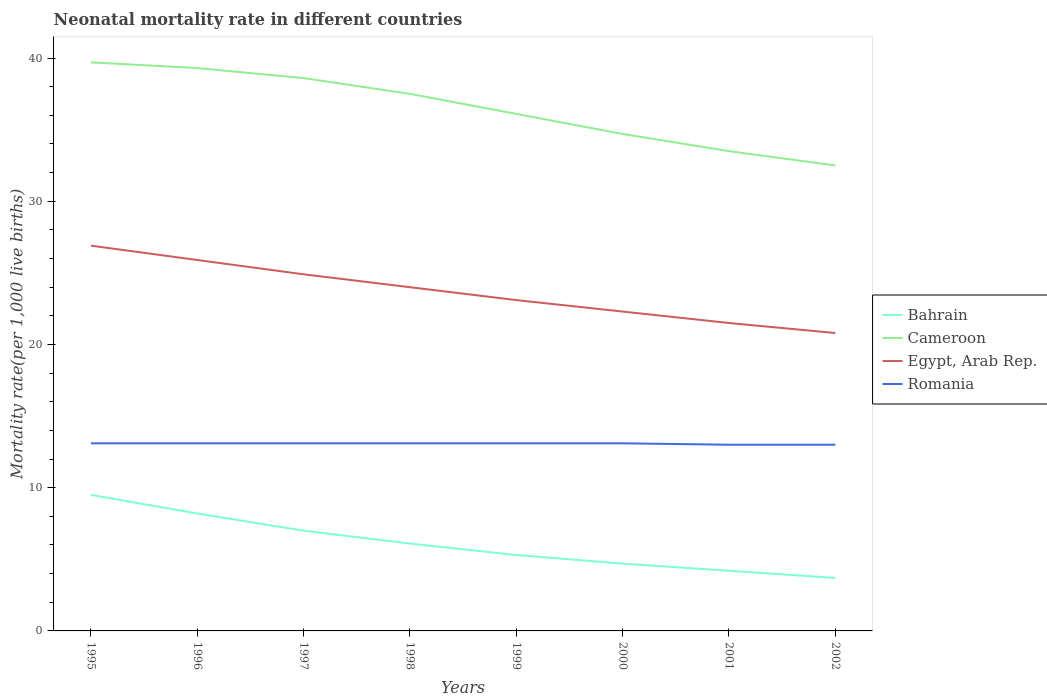How many different coloured lines are there?
Provide a short and direct response. 4. Does the line corresponding to Cameroon intersect with the line corresponding to Bahrain?
Offer a terse response. No. Is the number of lines equal to the number of legend labels?
Ensure brevity in your answer.  Yes. Across all years, what is the maximum neonatal mortality rate in Egypt, Arab Rep.?
Ensure brevity in your answer.  20.8. What is the difference between the highest and the lowest neonatal mortality rate in Cameroon?
Ensure brevity in your answer.  4. How many lines are there?
Provide a succinct answer. 4. Are the values on the major ticks of Y-axis written in scientific E-notation?
Your answer should be very brief. No. Where does the legend appear in the graph?
Your response must be concise. Center right. How many legend labels are there?
Your answer should be compact. 4. How are the legend labels stacked?
Ensure brevity in your answer.  Vertical. What is the title of the graph?
Ensure brevity in your answer.  Neonatal mortality rate in different countries. Does "Benin" appear as one of the legend labels in the graph?
Keep it short and to the point. No. What is the label or title of the X-axis?
Provide a short and direct response. Years. What is the label or title of the Y-axis?
Provide a succinct answer. Mortality rate(per 1,0 live births). What is the Mortality rate(per 1,000 live births) in Cameroon in 1995?
Give a very brief answer. 39.7. What is the Mortality rate(per 1,000 live births) in Egypt, Arab Rep. in 1995?
Your answer should be compact. 26.9. What is the Mortality rate(per 1,000 live births) in Romania in 1995?
Your answer should be very brief. 13.1. What is the Mortality rate(per 1,000 live births) of Cameroon in 1996?
Ensure brevity in your answer.  39.3. What is the Mortality rate(per 1,000 live births) in Egypt, Arab Rep. in 1996?
Your answer should be very brief. 25.9. What is the Mortality rate(per 1,000 live births) in Romania in 1996?
Offer a terse response. 13.1. What is the Mortality rate(per 1,000 live births) in Bahrain in 1997?
Give a very brief answer. 7. What is the Mortality rate(per 1,000 live births) of Cameroon in 1997?
Ensure brevity in your answer.  38.6. What is the Mortality rate(per 1,000 live births) of Egypt, Arab Rep. in 1997?
Offer a terse response. 24.9. What is the Mortality rate(per 1,000 live births) of Cameroon in 1998?
Offer a terse response. 37.5. What is the Mortality rate(per 1,000 live births) of Cameroon in 1999?
Your answer should be very brief. 36.1. What is the Mortality rate(per 1,000 live births) in Egypt, Arab Rep. in 1999?
Offer a terse response. 23.1. What is the Mortality rate(per 1,000 live births) in Romania in 1999?
Your answer should be very brief. 13.1. What is the Mortality rate(per 1,000 live births) in Bahrain in 2000?
Ensure brevity in your answer.  4.7. What is the Mortality rate(per 1,000 live births) in Cameroon in 2000?
Make the answer very short. 34.7. What is the Mortality rate(per 1,000 live births) in Egypt, Arab Rep. in 2000?
Your answer should be compact. 22.3. What is the Mortality rate(per 1,000 live births) in Romania in 2000?
Ensure brevity in your answer.  13.1. What is the Mortality rate(per 1,000 live births) of Bahrain in 2001?
Give a very brief answer. 4.2. What is the Mortality rate(per 1,000 live births) in Cameroon in 2001?
Offer a very short reply. 33.5. What is the Mortality rate(per 1,000 live births) in Romania in 2001?
Your response must be concise. 13. What is the Mortality rate(per 1,000 live births) in Cameroon in 2002?
Make the answer very short. 32.5. What is the Mortality rate(per 1,000 live births) in Egypt, Arab Rep. in 2002?
Provide a short and direct response. 20.8. Across all years, what is the maximum Mortality rate(per 1,000 live births) in Cameroon?
Provide a short and direct response. 39.7. Across all years, what is the maximum Mortality rate(per 1,000 live births) in Egypt, Arab Rep.?
Offer a terse response. 26.9. Across all years, what is the minimum Mortality rate(per 1,000 live births) in Cameroon?
Ensure brevity in your answer.  32.5. Across all years, what is the minimum Mortality rate(per 1,000 live births) in Egypt, Arab Rep.?
Give a very brief answer. 20.8. What is the total Mortality rate(per 1,000 live births) of Bahrain in the graph?
Offer a terse response. 48.7. What is the total Mortality rate(per 1,000 live births) of Cameroon in the graph?
Your answer should be compact. 291.9. What is the total Mortality rate(per 1,000 live births) of Egypt, Arab Rep. in the graph?
Keep it short and to the point. 189.4. What is the total Mortality rate(per 1,000 live births) in Romania in the graph?
Your answer should be compact. 104.6. What is the difference between the Mortality rate(per 1,000 live births) in Cameroon in 1995 and that in 1996?
Ensure brevity in your answer.  0.4. What is the difference between the Mortality rate(per 1,000 live births) in Egypt, Arab Rep. in 1995 and that in 1996?
Ensure brevity in your answer.  1. What is the difference between the Mortality rate(per 1,000 live births) of Romania in 1995 and that in 1996?
Your answer should be very brief. 0. What is the difference between the Mortality rate(per 1,000 live births) in Bahrain in 1995 and that in 1997?
Offer a very short reply. 2.5. What is the difference between the Mortality rate(per 1,000 live births) in Bahrain in 1995 and that in 1998?
Ensure brevity in your answer.  3.4. What is the difference between the Mortality rate(per 1,000 live births) in Cameroon in 1995 and that in 1998?
Offer a terse response. 2.2. What is the difference between the Mortality rate(per 1,000 live births) of Egypt, Arab Rep. in 1995 and that in 1998?
Ensure brevity in your answer.  2.9. What is the difference between the Mortality rate(per 1,000 live births) of Romania in 1995 and that in 1998?
Your answer should be compact. 0. What is the difference between the Mortality rate(per 1,000 live births) of Bahrain in 1995 and that in 1999?
Make the answer very short. 4.2. What is the difference between the Mortality rate(per 1,000 live births) of Cameroon in 1995 and that in 1999?
Your answer should be very brief. 3.6. What is the difference between the Mortality rate(per 1,000 live births) of Egypt, Arab Rep. in 1995 and that in 1999?
Keep it short and to the point. 3.8. What is the difference between the Mortality rate(per 1,000 live births) of Egypt, Arab Rep. in 1995 and that in 2000?
Keep it short and to the point. 4.6. What is the difference between the Mortality rate(per 1,000 live births) of Bahrain in 1995 and that in 2001?
Offer a terse response. 5.3. What is the difference between the Mortality rate(per 1,000 live births) of Romania in 1995 and that in 2001?
Keep it short and to the point. 0.1. What is the difference between the Mortality rate(per 1,000 live births) of Cameroon in 1995 and that in 2002?
Give a very brief answer. 7.2. What is the difference between the Mortality rate(per 1,000 live births) of Romania in 1995 and that in 2002?
Provide a short and direct response. 0.1. What is the difference between the Mortality rate(per 1,000 live births) in Bahrain in 1996 and that in 1997?
Provide a succinct answer. 1.2. What is the difference between the Mortality rate(per 1,000 live births) of Egypt, Arab Rep. in 1996 and that in 1997?
Offer a terse response. 1. What is the difference between the Mortality rate(per 1,000 live births) of Romania in 1996 and that in 1997?
Your answer should be very brief. 0. What is the difference between the Mortality rate(per 1,000 live births) in Egypt, Arab Rep. in 1996 and that in 1998?
Your answer should be compact. 1.9. What is the difference between the Mortality rate(per 1,000 live births) of Romania in 1996 and that in 1998?
Keep it short and to the point. 0. What is the difference between the Mortality rate(per 1,000 live births) of Bahrain in 1996 and that in 1999?
Provide a succinct answer. 2.9. What is the difference between the Mortality rate(per 1,000 live births) in Cameroon in 1996 and that in 1999?
Provide a short and direct response. 3.2. What is the difference between the Mortality rate(per 1,000 live births) of Romania in 1996 and that in 1999?
Offer a very short reply. 0. What is the difference between the Mortality rate(per 1,000 live births) in Bahrain in 1996 and that in 2000?
Ensure brevity in your answer.  3.5. What is the difference between the Mortality rate(per 1,000 live births) of Egypt, Arab Rep. in 1996 and that in 2000?
Offer a terse response. 3.6. What is the difference between the Mortality rate(per 1,000 live births) in Bahrain in 1996 and that in 2001?
Keep it short and to the point. 4. What is the difference between the Mortality rate(per 1,000 live births) of Cameroon in 1996 and that in 2001?
Offer a very short reply. 5.8. What is the difference between the Mortality rate(per 1,000 live births) in Egypt, Arab Rep. in 1996 and that in 2001?
Provide a short and direct response. 4.4. What is the difference between the Mortality rate(per 1,000 live births) of Egypt, Arab Rep. in 1996 and that in 2002?
Your answer should be compact. 5.1. What is the difference between the Mortality rate(per 1,000 live births) in Bahrain in 1997 and that in 1998?
Your answer should be compact. 0.9. What is the difference between the Mortality rate(per 1,000 live births) in Cameroon in 1997 and that in 1998?
Make the answer very short. 1.1. What is the difference between the Mortality rate(per 1,000 live births) in Egypt, Arab Rep. in 1997 and that in 1999?
Keep it short and to the point. 1.8. What is the difference between the Mortality rate(per 1,000 live births) of Romania in 1997 and that in 1999?
Provide a succinct answer. 0. What is the difference between the Mortality rate(per 1,000 live births) of Bahrain in 1997 and that in 2000?
Make the answer very short. 2.3. What is the difference between the Mortality rate(per 1,000 live births) of Cameroon in 1997 and that in 2000?
Provide a succinct answer. 3.9. What is the difference between the Mortality rate(per 1,000 live births) in Cameroon in 1997 and that in 2001?
Your answer should be compact. 5.1. What is the difference between the Mortality rate(per 1,000 live births) of Egypt, Arab Rep. in 1997 and that in 2001?
Give a very brief answer. 3.4. What is the difference between the Mortality rate(per 1,000 live births) of Bahrain in 1997 and that in 2002?
Make the answer very short. 3.3. What is the difference between the Mortality rate(per 1,000 live births) in Cameroon in 1997 and that in 2002?
Your response must be concise. 6.1. What is the difference between the Mortality rate(per 1,000 live births) of Egypt, Arab Rep. in 1997 and that in 2002?
Provide a short and direct response. 4.1. What is the difference between the Mortality rate(per 1,000 live births) of Bahrain in 1998 and that in 1999?
Provide a short and direct response. 0.8. What is the difference between the Mortality rate(per 1,000 live births) in Cameroon in 1998 and that in 1999?
Your answer should be compact. 1.4. What is the difference between the Mortality rate(per 1,000 live births) in Egypt, Arab Rep. in 1998 and that in 1999?
Your response must be concise. 0.9. What is the difference between the Mortality rate(per 1,000 live births) of Bahrain in 1998 and that in 2000?
Give a very brief answer. 1.4. What is the difference between the Mortality rate(per 1,000 live births) of Egypt, Arab Rep. in 1998 and that in 2000?
Provide a short and direct response. 1.7. What is the difference between the Mortality rate(per 1,000 live births) of Romania in 1998 and that in 2000?
Offer a very short reply. 0. What is the difference between the Mortality rate(per 1,000 live births) in Bahrain in 1998 and that in 2001?
Provide a short and direct response. 1.9. What is the difference between the Mortality rate(per 1,000 live births) in Bahrain in 1998 and that in 2002?
Your answer should be compact. 2.4. What is the difference between the Mortality rate(per 1,000 live births) of Egypt, Arab Rep. in 1998 and that in 2002?
Keep it short and to the point. 3.2. What is the difference between the Mortality rate(per 1,000 live births) of Cameroon in 1999 and that in 2000?
Your answer should be very brief. 1.4. What is the difference between the Mortality rate(per 1,000 live births) in Bahrain in 1999 and that in 2001?
Ensure brevity in your answer.  1.1. What is the difference between the Mortality rate(per 1,000 live births) of Romania in 1999 and that in 2001?
Your answer should be very brief. 0.1. What is the difference between the Mortality rate(per 1,000 live births) of Cameroon in 1999 and that in 2002?
Your response must be concise. 3.6. What is the difference between the Mortality rate(per 1,000 live births) in Cameroon in 2000 and that in 2001?
Provide a succinct answer. 1.2. What is the difference between the Mortality rate(per 1,000 live births) of Egypt, Arab Rep. in 2000 and that in 2001?
Your response must be concise. 0.8. What is the difference between the Mortality rate(per 1,000 live births) of Bahrain in 2000 and that in 2002?
Your response must be concise. 1. What is the difference between the Mortality rate(per 1,000 live births) in Egypt, Arab Rep. in 2000 and that in 2002?
Ensure brevity in your answer.  1.5. What is the difference between the Mortality rate(per 1,000 live births) in Bahrain in 1995 and the Mortality rate(per 1,000 live births) in Cameroon in 1996?
Provide a short and direct response. -29.8. What is the difference between the Mortality rate(per 1,000 live births) in Bahrain in 1995 and the Mortality rate(per 1,000 live births) in Egypt, Arab Rep. in 1996?
Give a very brief answer. -16.4. What is the difference between the Mortality rate(per 1,000 live births) of Cameroon in 1995 and the Mortality rate(per 1,000 live births) of Romania in 1996?
Ensure brevity in your answer.  26.6. What is the difference between the Mortality rate(per 1,000 live births) in Bahrain in 1995 and the Mortality rate(per 1,000 live births) in Cameroon in 1997?
Ensure brevity in your answer.  -29.1. What is the difference between the Mortality rate(per 1,000 live births) of Bahrain in 1995 and the Mortality rate(per 1,000 live births) of Egypt, Arab Rep. in 1997?
Provide a short and direct response. -15.4. What is the difference between the Mortality rate(per 1,000 live births) in Cameroon in 1995 and the Mortality rate(per 1,000 live births) in Egypt, Arab Rep. in 1997?
Give a very brief answer. 14.8. What is the difference between the Mortality rate(per 1,000 live births) of Cameroon in 1995 and the Mortality rate(per 1,000 live births) of Romania in 1997?
Offer a very short reply. 26.6. What is the difference between the Mortality rate(per 1,000 live births) in Bahrain in 1995 and the Mortality rate(per 1,000 live births) in Cameroon in 1998?
Make the answer very short. -28. What is the difference between the Mortality rate(per 1,000 live births) in Cameroon in 1995 and the Mortality rate(per 1,000 live births) in Romania in 1998?
Make the answer very short. 26.6. What is the difference between the Mortality rate(per 1,000 live births) in Bahrain in 1995 and the Mortality rate(per 1,000 live births) in Cameroon in 1999?
Provide a succinct answer. -26.6. What is the difference between the Mortality rate(per 1,000 live births) in Bahrain in 1995 and the Mortality rate(per 1,000 live births) in Romania in 1999?
Your answer should be very brief. -3.6. What is the difference between the Mortality rate(per 1,000 live births) in Cameroon in 1995 and the Mortality rate(per 1,000 live births) in Egypt, Arab Rep. in 1999?
Give a very brief answer. 16.6. What is the difference between the Mortality rate(per 1,000 live births) in Cameroon in 1995 and the Mortality rate(per 1,000 live births) in Romania in 1999?
Your response must be concise. 26.6. What is the difference between the Mortality rate(per 1,000 live births) in Egypt, Arab Rep. in 1995 and the Mortality rate(per 1,000 live births) in Romania in 1999?
Ensure brevity in your answer.  13.8. What is the difference between the Mortality rate(per 1,000 live births) in Bahrain in 1995 and the Mortality rate(per 1,000 live births) in Cameroon in 2000?
Keep it short and to the point. -25.2. What is the difference between the Mortality rate(per 1,000 live births) of Cameroon in 1995 and the Mortality rate(per 1,000 live births) of Egypt, Arab Rep. in 2000?
Give a very brief answer. 17.4. What is the difference between the Mortality rate(per 1,000 live births) of Cameroon in 1995 and the Mortality rate(per 1,000 live births) of Romania in 2000?
Your response must be concise. 26.6. What is the difference between the Mortality rate(per 1,000 live births) of Bahrain in 1995 and the Mortality rate(per 1,000 live births) of Cameroon in 2001?
Make the answer very short. -24. What is the difference between the Mortality rate(per 1,000 live births) in Bahrain in 1995 and the Mortality rate(per 1,000 live births) in Egypt, Arab Rep. in 2001?
Your answer should be very brief. -12. What is the difference between the Mortality rate(per 1,000 live births) of Bahrain in 1995 and the Mortality rate(per 1,000 live births) of Romania in 2001?
Your answer should be very brief. -3.5. What is the difference between the Mortality rate(per 1,000 live births) in Cameroon in 1995 and the Mortality rate(per 1,000 live births) in Romania in 2001?
Provide a short and direct response. 26.7. What is the difference between the Mortality rate(per 1,000 live births) in Bahrain in 1995 and the Mortality rate(per 1,000 live births) in Egypt, Arab Rep. in 2002?
Offer a very short reply. -11.3. What is the difference between the Mortality rate(per 1,000 live births) of Bahrain in 1995 and the Mortality rate(per 1,000 live births) of Romania in 2002?
Your response must be concise. -3.5. What is the difference between the Mortality rate(per 1,000 live births) of Cameroon in 1995 and the Mortality rate(per 1,000 live births) of Romania in 2002?
Give a very brief answer. 26.7. What is the difference between the Mortality rate(per 1,000 live births) of Egypt, Arab Rep. in 1995 and the Mortality rate(per 1,000 live births) of Romania in 2002?
Your answer should be compact. 13.9. What is the difference between the Mortality rate(per 1,000 live births) of Bahrain in 1996 and the Mortality rate(per 1,000 live births) of Cameroon in 1997?
Give a very brief answer. -30.4. What is the difference between the Mortality rate(per 1,000 live births) of Bahrain in 1996 and the Mortality rate(per 1,000 live births) of Egypt, Arab Rep. in 1997?
Offer a very short reply. -16.7. What is the difference between the Mortality rate(per 1,000 live births) of Cameroon in 1996 and the Mortality rate(per 1,000 live births) of Egypt, Arab Rep. in 1997?
Keep it short and to the point. 14.4. What is the difference between the Mortality rate(per 1,000 live births) of Cameroon in 1996 and the Mortality rate(per 1,000 live births) of Romania in 1997?
Offer a very short reply. 26.2. What is the difference between the Mortality rate(per 1,000 live births) of Bahrain in 1996 and the Mortality rate(per 1,000 live births) of Cameroon in 1998?
Provide a short and direct response. -29.3. What is the difference between the Mortality rate(per 1,000 live births) of Bahrain in 1996 and the Mortality rate(per 1,000 live births) of Egypt, Arab Rep. in 1998?
Your response must be concise. -15.8. What is the difference between the Mortality rate(per 1,000 live births) of Bahrain in 1996 and the Mortality rate(per 1,000 live births) of Romania in 1998?
Your response must be concise. -4.9. What is the difference between the Mortality rate(per 1,000 live births) of Cameroon in 1996 and the Mortality rate(per 1,000 live births) of Egypt, Arab Rep. in 1998?
Your answer should be very brief. 15.3. What is the difference between the Mortality rate(per 1,000 live births) of Cameroon in 1996 and the Mortality rate(per 1,000 live births) of Romania in 1998?
Provide a succinct answer. 26.2. What is the difference between the Mortality rate(per 1,000 live births) in Egypt, Arab Rep. in 1996 and the Mortality rate(per 1,000 live births) in Romania in 1998?
Make the answer very short. 12.8. What is the difference between the Mortality rate(per 1,000 live births) in Bahrain in 1996 and the Mortality rate(per 1,000 live births) in Cameroon in 1999?
Your answer should be compact. -27.9. What is the difference between the Mortality rate(per 1,000 live births) in Bahrain in 1996 and the Mortality rate(per 1,000 live births) in Egypt, Arab Rep. in 1999?
Give a very brief answer. -14.9. What is the difference between the Mortality rate(per 1,000 live births) of Cameroon in 1996 and the Mortality rate(per 1,000 live births) of Egypt, Arab Rep. in 1999?
Your response must be concise. 16.2. What is the difference between the Mortality rate(per 1,000 live births) of Cameroon in 1996 and the Mortality rate(per 1,000 live births) of Romania in 1999?
Offer a terse response. 26.2. What is the difference between the Mortality rate(per 1,000 live births) of Bahrain in 1996 and the Mortality rate(per 1,000 live births) of Cameroon in 2000?
Make the answer very short. -26.5. What is the difference between the Mortality rate(per 1,000 live births) in Bahrain in 1996 and the Mortality rate(per 1,000 live births) in Egypt, Arab Rep. in 2000?
Make the answer very short. -14.1. What is the difference between the Mortality rate(per 1,000 live births) in Cameroon in 1996 and the Mortality rate(per 1,000 live births) in Romania in 2000?
Keep it short and to the point. 26.2. What is the difference between the Mortality rate(per 1,000 live births) in Bahrain in 1996 and the Mortality rate(per 1,000 live births) in Cameroon in 2001?
Your answer should be very brief. -25.3. What is the difference between the Mortality rate(per 1,000 live births) in Bahrain in 1996 and the Mortality rate(per 1,000 live births) in Romania in 2001?
Provide a succinct answer. -4.8. What is the difference between the Mortality rate(per 1,000 live births) in Cameroon in 1996 and the Mortality rate(per 1,000 live births) in Egypt, Arab Rep. in 2001?
Ensure brevity in your answer.  17.8. What is the difference between the Mortality rate(per 1,000 live births) of Cameroon in 1996 and the Mortality rate(per 1,000 live births) of Romania in 2001?
Your answer should be very brief. 26.3. What is the difference between the Mortality rate(per 1,000 live births) in Bahrain in 1996 and the Mortality rate(per 1,000 live births) in Cameroon in 2002?
Make the answer very short. -24.3. What is the difference between the Mortality rate(per 1,000 live births) of Cameroon in 1996 and the Mortality rate(per 1,000 live births) of Romania in 2002?
Offer a terse response. 26.3. What is the difference between the Mortality rate(per 1,000 live births) in Bahrain in 1997 and the Mortality rate(per 1,000 live births) in Cameroon in 1998?
Give a very brief answer. -30.5. What is the difference between the Mortality rate(per 1,000 live births) in Bahrain in 1997 and the Mortality rate(per 1,000 live births) in Egypt, Arab Rep. in 1998?
Give a very brief answer. -17. What is the difference between the Mortality rate(per 1,000 live births) of Bahrain in 1997 and the Mortality rate(per 1,000 live births) of Romania in 1998?
Provide a succinct answer. -6.1. What is the difference between the Mortality rate(per 1,000 live births) of Cameroon in 1997 and the Mortality rate(per 1,000 live births) of Romania in 1998?
Ensure brevity in your answer.  25.5. What is the difference between the Mortality rate(per 1,000 live births) of Egypt, Arab Rep. in 1997 and the Mortality rate(per 1,000 live births) of Romania in 1998?
Your answer should be very brief. 11.8. What is the difference between the Mortality rate(per 1,000 live births) in Bahrain in 1997 and the Mortality rate(per 1,000 live births) in Cameroon in 1999?
Provide a succinct answer. -29.1. What is the difference between the Mortality rate(per 1,000 live births) of Bahrain in 1997 and the Mortality rate(per 1,000 live births) of Egypt, Arab Rep. in 1999?
Your answer should be very brief. -16.1. What is the difference between the Mortality rate(per 1,000 live births) in Cameroon in 1997 and the Mortality rate(per 1,000 live births) in Egypt, Arab Rep. in 1999?
Make the answer very short. 15.5. What is the difference between the Mortality rate(per 1,000 live births) in Egypt, Arab Rep. in 1997 and the Mortality rate(per 1,000 live births) in Romania in 1999?
Your answer should be very brief. 11.8. What is the difference between the Mortality rate(per 1,000 live births) in Bahrain in 1997 and the Mortality rate(per 1,000 live births) in Cameroon in 2000?
Your answer should be compact. -27.7. What is the difference between the Mortality rate(per 1,000 live births) in Bahrain in 1997 and the Mortality rate(per 1,000 live births) in Egypt, Arab Rep. in 2000?
Provide a short and direct response. -15.3. What is the difference between the Mortality rate(per 1,000 live births) in Cameroon in 1997 and the Mortality rate(per 1,000 live births) in Egypt, Arab Rep. in 2000?
Give a very brief answer. 16.3. What is the difference between the Mortality rate(per 1,000 live births) of Bahrain in 1997 and the Mortality rate(per 1,000 live births) of Cameroon in 2001?
Your answer should be compact. -26.5. What is the difference between the Mortality rate(per 1,000 live births) of Bahrain in 1997 and the Mortality rate(per 1,000 live births) of Romania in 2001?
Ensure brevity in your answer.  -6. What is the difference between the Mortality rate(per 1,000 live births) in Cameroon in 1997 and the Mortality rate(per 1,000 live births) in Egypt, Arab Rep. in 2001?
Ensure brevity in your answer.  17.1. What is the difference between the Mortality rate(per 1,000 live births) of Cameroon in 1997 and the Mortality rate(per 1,000 live births) of Romania in 2001?
Keep it short and to the point. 25.6. What is the difference between the Mortality rate(per 1,000 live births) in Egypt, Arab Rep. in 1997 and the Mortality rate(per 1,000 live births) in Romania in 2001?
Give a very brief answer. 11.9. What is the difference between the Mortality rate(per 1,000 live births) of Bahrain in 1997 and the Mortality rate(per 1,000 live births) of Cameroon in 2002?
Give a very brief answer. -25.5. What is the difference between the Mortality rate(per 1,000 live births) of Bahrain in 1997 and the Mortality rate(per 1,000 live births) of Egypt, Arab Rep. in 2002?
Offer a very short reply. -13.8. What is the difference between the Mortality rate(per 1,000 live births) of Bahrain in 1997 and the Mortality rate(per 1,000 live births) of Romania in 2002?
Keep it short and to the point. -6. What is the difference between the Mortality rate(per 1,000 live births) of Cameroon in 1997 and the Mortality rate(per 1,000 live births) of Romania in 2002?
Offer a very short reply. 25.6. What is the difference between the Mortality rate(per 1,000 live births) in Egypt, Arab Rep. in 1997 and the Mortality rate(per 1,000 live births) in Romania in 2002?
Keep it short and to the point. 11.9. What is the difference between the Mortality rate(per 1,000 live births) in Bahrain in 1998 and the Mortality rate(per 1,000 live births) in Egypt, Arab Rep. in 1999?
Your response must be concise. -17. What is the difference between the Mortality rate(per 1,000 live births) of Bahrain in 1998 and the Mortality rate(per 1,000 live births) of Romania in 1999?
Ensure brevity in your answer.  -7. What is the difference between the Mortality rate(per 1,000 live births) in Cameroon in 1998 and the Mortality rate(per 1,000 live births) in Romania in 1999?
Provide a succinct answer. 24.4. What is the difference between the Mortality rate(per 1,000 live births) in Bahrain in 1998 and the Mortality rate(per 1,000 live births) in Cameroon in 2000?
Make the answer very short. -28.6. What is the difference between the Mortality rate(per 1,000 live births) of Bahrain in 1998 and the Mortality rate(per 1,000 live births) of Egypt, Arab Rep. in 2000?
Keep it short and to the point. -16.2. What is the difference between the Mortality rate(per 1,000 live births) of Bahrain in 1998 and the Mortality rate(per 1,000 live births) of Romania in 2000?
Give a very brief answer. -7. What is the difference between the Mortality rate(per 1,000 live births) of Cameroon in 1998 and the Mortality rate(per 1,000 live births) of Egypt, Arab Rep. in 2000?
Ensure brevity in your answer.  15.2. What is the difference between the Mortality rate(per 1,000 live births) of Cameroon in 1998 and the Mortality rate(per 1,000 live births) of Romania in 2000?
Make the answer very short. 24.4. What is the difference between the Mortality rate(per 1,000 live births) of Egypt, Arab Rep. in 1998 and the Mortality rate(per 1,000 live births) of Romania in 2000?
Provide a short and direct response. 10.9. What is the difference between the Mortality rate(per 1,000 live births) in Bahrain in 1998 and the Mortality rate(per 1,000 live births) in Cameroon in 2001?
Your answer should be very brief. -27.4. What is the difference between the Mortality rate(per 1,000 live births) in Bahrain in 1998 and the Mortality rate(per 1,000 live births) in Egypt, Arab Rep. in 2001?
Your answer should be compact. -15.4. What is the difference between the Mortality rate(per 1,000 live births) in Bahrain in 1998 and the Mortality rate(per 1,000 live births) in Cameroon in 2002?
Offer a terse response. -26.4. What is the difference between the Mortality rate(per 1,000 live births) in Bahrain in 1998 and the Mortality rate(per 1,000 live births) in Egypt, Arab Rep. in 2002?
Provide a succinct answer. -14.7. What is the difference between the Mortality rate(per 1,000 live births) of Bahrain in 1998 and the Mortality rate(per 1,000 live births) of Romania in 2002?
Your response must be concise. -6.9. What is the difference between the Mortality rate(per 1,000 live births) of Cameroon in 1998 and the Mortality rate(per 1,000 live births) of Romania in 2002?
Provide a short and direct response. 24.5. What is the difference between the Mortality rate(per 1,000 live births) in Egypt, Arab Rep. in 1998 and the Mortality rate(per 1,000 live births) in Romania in 2002?
Give a very brief answer. 11. What is the difference between the Mortality rate(per 1,000 live births) in Bahrain in 1999 and the Mortality rate(per 1,000 live births) in Cameroon in 2000?
Provide a succinct answer. -29.4. What is the difference between the Mortality rate(per 1,000 live births) of Cameroon in 1999 and the Mortality rate(per 1,000 live births) of Romania in 2000?
Ensure brevity in your answer.  23. What is the difference between the Mortality rate(per 1,000 live births) of Bahrain in 1999 and the Mortality rate(per 1,000 live births) of Cameroon in 2001?
Offer a very short reply. -28.2. What is the difference between the Mortality rate(per 1,000 live births) in Bahrain in 1999 and the Mortality rate(per 1,000 live births) in Egypt, Arab Rep. in 2001?
Provide a short and direct response. -16.2. What is the difference between the Mortality rate(per 1,000 live births) of Cameroon in 1999 and the Mortality rate(per 1,000 live births) of Egypt, Arab Rep. in 2001?
Offer a very short reply. 14.6. What is the difference between the Mortality rate(per 1,000 live births) in Cameroon in 1999 and the Mortality rate(per 1,000 live births) in Romania in 2001?
Make the answer very short. 23.1. What is the difference between the Mortality rate(per 1,000 live births) of Bahrain in 1999 and the Mortality rate(per 1,000 live births) of Cameroon in 2002?
Your answer should be compact. -27.2. What is the difference between the Mortality rate(per 1,000 live births) in Bahrain in 1999 and the Mortality rate(per 1,000 live births) in Egypt, Arab Rep. in 2002?
Make the answer very short. -15.5. What is the difference between the Mortality rate(per 1,000 live births) of Bahrain in 1999 and the Mortality rate(per 1,000 live births) of Romania in 2002?
Your answer should be compact. -7.7. What is the difference between the Mortality rate(per 1,000 live births) of Cameroon in 1999 and the Mortality rate(per 1,000 live births) of Egypt, Arab Rep. in 2002?
Your answer should be very brief. 15.3. What is the difference between the Mortality rate(per 1,000 live births) in Cameroon in 1999 and the Mortality rate(per 1,000 live births) in Romania in 2002?
Provide a succinct answer. 23.1. What is the difference between the Mortality rate(per 1,000 live births) in Egypt, Arab Rep. in 1999 and the Mortality rate(per 1,000 live births) in Romania in 2002?
Make the answer very short. 10.1. What is the difference between the Mortality rate(per 1,000 live births) in Bahrain in 2000 and the Mortality rate(per 1,000 live births) in Cameroon in 2001?
Your answer should be very brief. -28.8. What is the difference between the Mortality rate(per 1,000 live births) of Bahrain in 2000 and the Mortality rate(per 1,000 live births) of Egypt, Arab Rep. in 2001?
Ensure brevity in your answer.  -16.8. What is the difference between the Mortality rate(per 1,000 live births) in Bahrain in 2000 and the Mortality rate(per 1,000 live births) in Romania in 2001?
Offer a very short reply. -8.3. What is the difference between the Mortality rate(per 1,000 live births) of Cameroon in 2000 and the Mortality rate(per 1,000 live births) of Egypt, Arab Rep. in 2001?
Provide a short and direct response. 13.2. What is the difference between the Mortality rate(per 1,000 live births) of Cameroon in 2000 and the Mortality rate(per 1,000 live births) of Romania in 2001?
Your response must be concise. 21.7. What is the difference between the Mortality rate(per 1,000 live births) in Bahrain in 2000 and the Mortality rate(per 1,000 live births) in Cameroon in 2002?
Your answer should be very brief. -27.8. What is the difference between the Mortality rate(per 1,000 live births) of Bahrain in 2000 and the Mortality rate(per 1,000 live births) of Egypt, Arab Rep. in 2002?
Give a very brief answer. -16.1. What is the difference between the Mortality rate(per 1,000 live births) of Bahrain in 2000 and the Mortality rate(per 1,000 live births) of Romania in 2002?
Offer a very short reply. -8.3. What is the difference between the Mortality rate(per 1,000 live births) in Cameroon in 2000 and the Mortality rate(per 1,000 live births) in Egypt, Arab Rep. in 2002?
Your response must be concise. 13.9. What is the difference between the Mortality rate(per 1,000 live births) of Cameroon in 2000 and the Mortality rate(per 1,000 live births) of Romania in 2002?
Your response must be concise. 21.7. What is the difference between the Mortality rate(per 1,000 live births) of Egypt, Arab Rep. in 2000 and the Mortality rate(per 1,000 live births) of Romania in 2002?
Ensure brevity in your answer.  9.3. What is the difference between the Mortality rate(per 1,000 live births) of Bahrain in 2001 and the Mortality rate(per 1,000 live births) of Cameroon in 2002?
Keep it short and to the point. -28.3. What is the difference between the Mortality rate(per 1,000 live births) of Bahrain in 2001 and the Mortality rate(per 1,000 live births) of Egypt, Arab Rep. in 2002?
Keep it short and to the point. -16.6. What is the difference between the Mortality rate(per 1,000 live births) of Egypt, Arab Rep. in 2001 and the Mortality rate(per 1,000 live births) of Romania in 2002?
Your response must be concise. 8.5. What is the average Mortality rate(per 1,000 live births) in Bahrain per year?
Your response must be concise. 6.09. What is the average Mortality rate(per 1,000 live births) of Cameroon per year?
Offer a terse response. 36.49. What is the average Mortality rate(per 1,000 live births) in Egypt, Arab Rep. per year?
Give a very brief answer. 23.68. What is the average Mortality rate(per 1,000 live births) of Romania per year?
Make the answer very short. 13.07. In the year 1995, what is the difference between the Mortality rate(per 1,000 live births) in Bahrain and Mortality rate(per 1,000 live births) in Cameroon?
Your answer should be very brief. -30.2. In the year 1995, what is the difference between the Mortality rate(per 1,000 live births) of Bahrain and Mortality rate(per 1,000 live births) of Egypt, Arab Rep.?
Offer a very short reply. -17.4. In the year 1995, what is the difference between the Mortality rate(per 1,000 live births) of Bahrain and Mortality rate(per 1,000 live births) of Romania?
Your answer should be compact. -3.6. In the year 1995, what is the difference between the Mortality rate(per 1,000 live births) of Cameroon and Mortality rate(per 1,000 live births) of Romania?
Your answer should be compact. 26.6. In the year 1996, what is the difference between the Mortality rate(per 1,000 live births) in Bahrain and Mortality rate(per 1,000 live births) in Cameroon?
Give a very brief answer. -31.1. In the year 1996, what is the difference between the Mortality rate(per 1,000 live births) of Bahrain and Mortality rate(per 1,000 live births) of Egypt, Arab Rep.?
Make the answer very short. -17.7. In the year 1996, what is the difference between the Mortality rate(per 1,000 live births) in Cameroon and Mortality rate(per 1,000 live births) in Egypt, Arab Rep.?
Offer a very short reply. 13.4. In the year 1996, what is the difference between the Mortality rate(per 1,000 live births) of Cameroon and Mortality rate(per 1,000 live births) of Romania?
Your answer should be very brief. 26.2. In the year 1996, what is the difference between the Mortality rate(per 1,000 live births) of Egypt, Arab Rep. and Mortality rate(per 1,000 live births) of Romania?
Provide a succinct answer. 12.8. In the year 1997, what is the difference between the Mortality rate(per 1,000 live births) of Bahrain and Mortality rate(per 1,000 live births) of Cameroon?
Your answer should be very brief. -31.6. In the year 1997, what is the difference between the Mortality rate(per 1,000 live births) in Bahrain and Mortality rate(per 1,000 live births) in Egypt, Arab Rep.?
Your answer should be compact. -17.9. In the year 1997, what is the difference between the Mortality rate(per 1,000 live births) in Cameroon and Mortality rate(per 1,000 live births) in Egypt, Arab Rep.?
Your answer should be compact. 13.7. In the year 1997, what is the difference between the Mortality rate(per 1,000 live births) in Egypt, Arab Rep. and Mortality rate(per 1,000 live births) in Romania?
Ensure brevity in your answer.  11.8. In the year 1998, what is the difference between the Mortality rate(per 1,000 live births) in Bahrain and Mortality rate(per 1,000 live births) in Cameroon?
Ensure brevity in your answer.  -31.4. In the year 1998, what is the difference between the Mortality rate(per 1,000 live births) of Bahrain and Mortality rate(per 1,000 live births) of Egypt, Arab Rep.?
Your answer should be compact. -17.9. In the year 1998, what is the difference between the Mortality rate(per 1,000 live births) in Bahrain and Mortality rate(per 1,000 live births) in Romania?
Give a very brief answer. -7. In the year 1998, what is the difference between the Mortality rate(per 1,000 live births) in Cameroon and Mortality rate(per 1,000 live births) in Egypt, Arab Rep.?
Provide a succinct answer. 13.5. In the year 1998, what is the difference between the Mortality rate(per 1,000 live births) of Cameroon and Mortality rate(per 1,000 live births) of Romania?
Offer a very short reply. 24.4. In the year 1999, what is the difference between the Mortality rate(per 1,000 live births) of Bahrain and Mortality rate(per 1,000 live births) of Cameroon?
Give a very brief answer. -30.8. In the year 1999, what is the difference between the Mortality rate(per 1,000 live births) in Bahrain and Mortality rate(per 1,000 live births) in Egypt, Arab Rep.?
Make the answer very short. -17.8. In the year 1999, what is the difference between the Mortality rate(per 1,000 live births) of Bahrain and Mortality rate(per 1,000 live births) of Romania?
Keep it short and to the point. -7.8. In the year 1999, what is the difference between the Mortality rate(per 1,000 live births) in Egypt, Arab Rep. and Mortality rate(per 1,000 live births) in Romania?
Make the answer very short. 10. In the year 2000, what is the difference between the Mortality rate(per 1,000 live births) in Bahrain and Mortality rate(per 1,000 live births) in Cameroon?
Offer a very short reply. -30. In the year 2000, what is the difference between the Mortality rate(per 1,000 live births) of Bahrain and Mortality rate(per 1,000 live births) of Egypt, Arab Rep.?
Offer a very short reply. -17.6. In the year 2000, what is the difference between the Mortality rate(per 1,000 live births) of Cameroon and Mortality rate(per 1,000 live births) of Romania?
Offer a very short reply. 21.6. In the year 2001, what is the difference between the Mortality rate(per 1,000 live births) in Bahrain and Mortality rate(per 1,000 live births) in Cameroon?
Provide a succinct answer. -29.3. In the year 2001, what is the difference between the Mortality rate(per 1,000 live births) in Bahrain and Mortality rate(per 1,000 live births) in Egypt, Arab Rep.?
Your answer should be very brief. -17.3. In the year 2001, what is the difference between the Mortality rate(per 1,000 live births) of Bahrain and Mortality rate(per 1,000 live births) of Romania?
Offer a terse response. -8.8. In the year 2001, what is the difference between the Mortality rate(per 1,000 live births) of Cameroon and Mortality rate(per 1,000 live births) of Romania?
Make the answer very short. 20.5. In the year 2002, what is the difference between the Mortality rate(per 1,000 live births) of Bahrain and Mortality rate(per 1,000 live births) of Cameroon?
Offer a very short reply. -28.8. In the year 2002, what is the difference between the Mortality rate(per 1,000 live births) in Bahrain and Mortality rate(per 1,000 live births) in Egypt, Arab Rep.?
Your answer should be compact. -17.1. In the year 2002, what is the difference between the Mortality rate(per 1,000 live births) of Bahrain and Mortality rate(per 1,000 live births) of Romania?
Make the answer very short. -9.3. In the year 2002, what is the difference between the Mortality rate(per 1,000 live births) in Cameroon and Mortality rate(per 1,000 live births) in Romania?
Your response must be concise. 19.5. In the year 2002, what is the difference between the Mortality rate(per 1,000 live births) in Egypt, Arab Rep. and Mortality rate(per 1,000 live births) in Romania?
Your answer should be compact. 7.8. What is the ratio of the Mortality rate(per 1,000 live births) of Bahrain in 1995 to that in 1996?
Offer a terse response. 1.16. What is the ratio of the Mortality rate(per 1,000 live births) in Cameroon in 1995 to that in 1996?
Make the answer very short. 1.01. What is the ratio of the Mortality rate(per 1,000 live births) in Egypt, Arab Rep. in 1995 to that in 1996?
Ensure brevity in your answer.  1.04. What is the ratio of the Mortality rate(per 1,000 live births) of Bahrain in 1995 to that in 1997?
Your response must be concise. 1.36. What is the ratio of the Mortality rate(per 1,000 live births) of Cameroon in 1995 to that in 1997?
Give a very brief answer. 1.03. What is the ratio of the Mortality rate(per 1,000 live births) of Egypt, Arab Rep. in 1995 to that in 1997?
Provide a short and direct response. 1.08. What is the ratio of the Mortality rate(per 1,000 live births) in Romania in 1995 to that in 1997?
Offer a terse response. 1. What is the ratio of the Mortality rate(per 1,000 live births) in Bahrain in 1995 to that in 1998?
Offer a very short reply. 1.56. What is the ratio of the Mortality rate(per 1,000 live births) in Cameroon in 1995 to that in 1998?
Offer a very short reply. 1.06. What is the ratio of the Mortality rate(per 1,000 live births) in Egypt, Arab Rep. in 1995 to that in 1998?
Your answer should be compact. 1.12. What is the ratio of the Mortality rate(per 1,000 live births) in Bahrain in 1995 to that in 1999?
Offer a very short reply. 1.79. What is the ratio of the Mortality rate(per 1,000 live births) in Cameroon in 1995 to that in 1999?
Provide a short and direct response. 1.1. What is the ratio of the Mortality rate(per 1,000 live births) of Egypt, Arab Rep. in 1995 to that in 1999?
Your answer should be very brief. 1.16. What is the ratio of the Mortality rate(per 1,000 live births) of Bahrain in 1995 to that in 2000?
Your answer should be compact. 2.02. What is the ratio of the Mortality rate(per 1,000 live births) of Cameroon in 1995 to that in 2000?
Your answer should be very brief. 1.14. What is the ratio of the Mortality rate(per 1,000 live births) of Egypt, Arab Rep. in 1995 to that in 2000?
Provide a succinct answer. 1.21. What is the ratio of the Mortality rate(per 1,000 live births) in Romania in 1995 to that in 2000?
Make the answer very short. 1. What is the ratio of the Mortality rate(per 1,000 live births) of Bahrain in 1995 to that in 2001?
Offer a terse response. 2.26. What is the ratio of the Mortality rate(per 1,000 live births) of Cameroon in 1995 to that in 2001?
Your response must be concise. 1.19. What is the ratio of the Mortality rate(per 1,000 live births) in Egypt, Arab Rep. in 1995 to that in 2001?
Your response must be concise. 1.25. What is the ratio of the Mortality rate(per 1,000 live births) of Romania in 1995 to that in 2001?
Your answer should be very brief. 1.01. What is the ratio of the Mortality rate(per 1,000 live births) of Bahrain in 1995 to that in 2002?
Keep it short and to the point. 2.57. What is the ratio of the Mortality rate(per 1,000 live births) of Cameroon in 1995 to that in 2002?
Offer a very short reply. 1.22. What is the ratio of the Mortality rate(per 1,000 live births) of Egypt, Arab Rep. in 1995 to that in 2002?
Provide a succinct answer. 1.29. What is the ratio of the Mortality rate(per 1,000 live births) of Romania in 1995 to that in 2002?
Your answer should be compact. 1.01. What is the ratio of the Mortality rate(per 1,000 live births) of Bahrain in 1996 to that in 1997?
Offer a very short reply. 1.17. What is the ratio of the Mortality rate(per 1,000 live births) in Cameroon in 1996 to that in 1997?
Your response must be concise. 1.02. What is the ratio of the Mortality rate(per 1,000 live births) of Egypt, Arab Rep. in 1996 to that in 1997?
Ensure brevity in your answer.  1.04. What is the ratio of the Mortality rate(per 1,000 live births) of Romania in 1996 to that in 1997?
Your response must be concise. 1. What is the ratio of the Mortality rate(per 1,000 live births) of Bahrain in 1996 to that in 1998?
Provide a succinct answer. 1.34. What is the ratio of the Mortality rate(per 1,000 live births) of Cameroon in 1996 to that in 1998?
Ensure brevity in your answer.  1.05. What is the ratio of the Mortality rate(per 1,000 live births) of Egypt, Arab Rep. in 1996 to that in 1998?
Offer a very short reply. 1.08. What is the ratio of the Mortality rate(per 1,000 live births) in Bahrain in 1996 to that in 1999?
Provide a short and direct response. 1.55. What is the ratio of the Mortality rate(per 1,000 live births) in Cameroon in 1996 to that in 1999?
Provide a succinct answer. 1.09. What is the ratio of the Mortality rate(per 1,000 live births) in Egypt, Arab Rep. in 1996 to that in 1999?
Offer a terse response. 1.12. What is the ratio of the Mortality rate(per 1,000 live births) in Romania in 1996 to that in 1999?
Make the answer very short. 1. What is the ratio of the Mortality rate(per 1,000 live births) of Bahrain in 1996 to that in 2000?
Give a very brief answer. 1.74. What is the ratio of the Mortality rate(per 1,000 live births) in Cameroon in 1996 to that in 2000?
Ensure brevity in your answer.  1.13. What is the ratio of the Mortality rate(per 1,000 live births) of Egypt, Arab Rep. in 1996 to that in 2000?
Make the answer very short. 1.16. What is the ratio of the Mortality rate(per 1,000 live births) of Romania in 1996 to that in 2000?
Your response must be concise. 1. What is the ratio of the Mortality rate(per 1,000 live births) of Bahrain in 1996 to that in 2001?
Offer a terse response. 1.95. What is the ratio of the Mortality rate(per 1,000 live births) of Cameroon in 1996 to that in 2001?
Ensure brevity in your answer.  1.17. What is the ratio of the Mortality rate(per 1,000 live births) of Egypt, Arab Rep. in 1996 to that in 2001?
Your answer should be compact. 1.2. What is the ratio of the Mortality rate(per 1,000 live births) in Romania in 1996 to that in 2001?
Provide a short and direct response. 1.01. What is the ratio of the Mortality rate(per 1,000 live births) in Bahrain in 1996 to that in 2002?
Provide a short and direct response. 2.22. What is the ratio of the Mortality rate(per 1,000 live births) of Cameroon in 1996 to that in 2002?
Provide a short and direct response. 1.21. What is the ratio of the Mortality rate(per 1,000 live births) in Egypt, Arab Rep. in 1996 to that in 2002?
Ensure brevity in your answer.  1.25. What is the ratio of the Mortality rate(per 1,000 live births) in Romania in 1996 to that in 2002?
Provide a short and direct response. 1.01. What is the ratio of the Mortality rate(per 1,000 live births) of Bahrain in 1997 to that in 1998?
Your answer should be very brief. 1.15. What is the ratio of the Mortality rate(per 1,000 live births) of Cameroon in 1997 to that in 1998?
Offer a terse response. 1.03. What is the ratio of the Mortality rate(per 1,000 live births) of Egypt, Arab Rep. in 1997 to that in 1998?
Make the answer very short. 1.04. What is the ratio of the Mortality rate(per 1,000 live births) in Romania in 1997 to that in 1998?
Ensure brevity in your answer.  1. What is the ratio of the Mortality rate(per 1,000 live births) in Bahrain in 1997 to that in 1999?
Give a very brief answer. 1.32. What is the ratio of the Mortality rate(per 1,000 live births) of Cameroon in 1997 to that in 1999?
Offer a very short reply. 1.07. What is the ratio of the Mortality rate(per 1,000 live births) in Egypt, Arab Rep. in 1997 to that in 1999?
Provide a succinct answer. 1.08. What is the ratio of the Mortality rate(per 1,000 live births) of Romania in 1997 to that in 1999?
Offer a very short reply. 1. What is the ratio of the Mortality rate(per 1,000 live births) in Bahrain in 1997 to that in 2000?
Your answer should be compact. 1.49. What is the ratio of the Mortality rate(per 1,000 live births) in Cameroon in 1997 to that in 2000?
Your answer should be very brief. 1.11. What is the ratio of the Mortality rate(per 1,000 live births) in Egypt, Arab Rep. in 1997 to that in 2000?
Your answer should be very brief. 1.12. What is the ratio of the Mortality rate(per 1,000 live births) in Bahrain in 1997 to that in 2001?
Make the answer very short. 1.67. What is the ratio of the Mortality rate(per 1,000 live births) of Cameroon in 1997 to that in 2001?
Ensure brevity in your answer.  1.15. What is the ratio of the Mortality rate(per 1,000 live births) of Egypt, Arab Rep. in 1997 to that in 2001?
Provide a short and direct response. 1.16. What is the ratio of the Mortality rate(per 1,000 live births) in Romania in 1997 to that in 2001?
Make the answer very short. 1.01. What is the ratio of the Mortality rate(per 1,000 live births) in Bahrain in 1997 to that in 2002?
Your answer should be very brief. 1.89. What is the ratio of the Mortality rate(per 1,000 live births) in Cameroon in 1997 to that in 2002?
Your response must be concise. 1.19. What is the ratio of the Mortality rate(per 1,000 live births) of Egypt, Arab Rep. in 1997 to that in 2002?
Make the answer very short. 1.2. What is the ratio of the Mortality rate(per 1,000 live births) of Romania in 1997 to that in 2002?
Your answer should be compact. 1.01. What is the ratio of the Mortality rate(per 1,000 live births) in Bahrain in 1998 to that in 1999?
Your answer should be very brief. 1.15. What is the ratio of the Mortality rate(per 1,000 live births) in Cameroon in 1998 to that in 1999?
Make the answer very short. 1.04. What is the ratio of the Mortality rate(per 1,000 live births) of Egypt, Arab Rep. in 1998 to that in 1999?
Keep it short and to the point. 1.04. What is the ratio of the Mortality rate(per 1,000 live births) of Romania in 1998 to that in 1999?
Keep it short and to the point. 1. What is the ratio of the Mortality rate(per 1,000 live births) of Bahrain in 1998 to that in 2000?
Make the answer very short. 1.3. What is the ratio of the Mortality rate(per 1,000 live births) in Cameroon in 1998 to that in 2000?
Offer a very short reply. 1.08. What is the ratio of the Mortality rate(per 1,000 live births) of Egypt, Arab Rep. in 1998 to that in 2000?
Make the answer very short. 1.08. What is the ratio of the Mortality rate(per 1,000 live births) of Romania in 1998 to that in 2000?
Your answer should be compact. 1. What is the ratio of the Mortality rate(per 1,000 live births) in Bahrain in 1998 to that in 2001?
Give a very brief answer. 1.45. What is the ratio of the Mortality rate(per 1,000 live births) in Cameroon in 1998 to that in 2001?
Ensure brevity in your answer.  1.12. What is the ratio of the Mortality rate(per 1,000 live births) of Egypt, Arab Rep. in 1998 to that in 2001?
Provide a succinct answer. 1.12. What is the ratio of the Mortality rate(per 1,000 live births) of Romania in 1998 to that in 2001?
Offer a terse response. 1.01. What is the ratio of the Mortality rate(per 1,000 live births) in Bahrain in 1998 to that in 2002?
Your response must be concise. 1.65. What is the ratio of the Mortality rate(per 1,000 live births) in Cameroon in 1998 to that in 2002?
Keep it short and to the point. 1.15. What is the ratio of the Mortality rate(per 1,000 live births) in Egypt, Arab Rep. in 1998 to that in 2002?
Give a very brief answer. 1.15. What is the ratio of the Mortality rate(per 1,000 live births) in Romania in 1998 to that in 2002?
Your answer should be compact. 1.01. What is the ratio of the Mortality rate(per 1,000 live births) of Bahrain in 1999 to that in 2000?
Give a very brief answer. 1.13. What is the ratio of the Mortality rate(per 1,000 live births) in Cameroon in 1999 to that in 2000?
Provide a short and direct response. 1.04. What is the ratio of the Mortality rate(per 1,000 live births) of Egypt, Arab Rep. in 1999 to that in 2000?
Ensure brevity in your answer.  1.04. What is the ratio of the Mortality rate(per 1,000 live births) of Bahrain in 1999 to that in 2001?
Your answer should be compact. 1.26. What is the ratio of the Mortality rate(per 1,000 live births) of Cameroon in 1999 to that in 2001?
Provide a succinct answer. 1.08. What is the ratio of the Mortality rate(per 1,000 live births) of Egypt, Arab Rep. in 1999 to that in 2001?
Your answer should be very brief. 1.07. What is the ratio of the Mortality rate(per 1,000 live births) in Romania in 1999 to that in 2001?
Make the answer very short. 1.01. What is the ratio of the Mortality rate(per 1,000 live births) in Bahrain in 1999 to that in 2002?
Provide a succinct answer. 1.43. What is the ratio of the Mortality rate(per 1,000 live births) of Cameroon in 1999 to that in 2002?
Provide a succinct answer. 1.11. What is the ratio of the Mortality rate(per 1,000 live births) of Egypt, Arab Rep. in 1999 to that in 2002?
Your answer should be compact. 1.11. What is the ratio of the Mortality rate(per 1,000 live births) of Romania in 1999 to that in 2002?
Give a very brief answer. 1.01. What is the ratio of the Mortality rate(per 1,000 live births) of Bahrain in 2000 to that in 2001?
Your answer should be compact. 1.12. What is the ratio of the Mortality rate(per 1,000 live births) in Cameroon in 2000 to that in 2001?
Keep it short and to the point. 1.04. What is the ratio of the Mortality rate(per 1,000 live births) in Egypt, Arab Rep. in 2000 to that in 2001?
Offer a terse response. 1.04. What is the ratio of the Mortality rate(per 1,000 live births) of Romania in 2000 to that in 2001?
Provide a succinct answer. 1.01. What is the ratio of the Mortality rate(per 1,000 live births) of Bahrain in 2000 to that in 2002?
Your answer should be very brief. 1.27. What is the ratio of the Mortality rate(per 1,000 live births) of Cameroon in 2000 to that in 2002?
Give a very brief answer. 1.07. What is the ratio of the Mortality rate(per 1,000 live births) of Egypt, Arab Rep. in 2000 to that in 2002?
Offer a terse response. 1.07. What is the ratio of the Mortality rate(per 1,000 live births) of Romania in 2000 to that in 2002?
Your response must be concise. 1.01. What is the ratio of the Mortality rate(per 1,000 live births) in Bahrain in 2001 to that in 2002?
Offer a terse response. 1.14. What is the ratio of the Mortality rate(per 1,000 live births) of Cameroon in 2001 to that in 2002?
Keep it short and to the point. 1.03. What is the ratio of the Mortality rate(per 1,000 live births) of Egypt, Arab Rep. in 2001 to that in 2002?
Give a very brief answer. 1.03. What is the difference between the highest and the second highest Mortality rate(per 1,000 live births) in Cameroon?
Make the answer very short. 0.4. What is the difference between the highest and the lowest Mortality rate(per 1,000 live births) in Bahrain?
Ensure brevity in your answer.  5.8. What is the difference between the highest and the lowest Mortality rate(per 1,000 live births) in Egypt, Arab Rep.?
Your response must be concise. 6.1. 